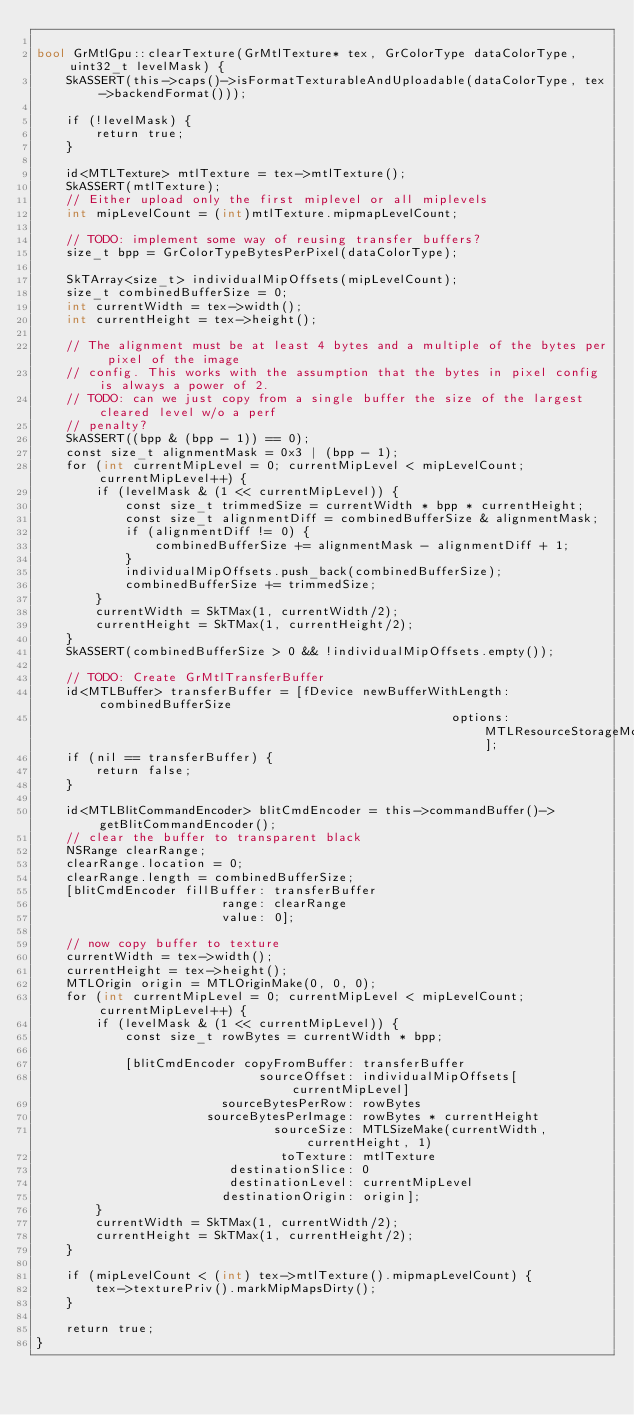<code> <loc_0><loc_0><loc_500><loc_500><_ObjectiveC_>
bool GrMtlGpu::clearTexture(GrMtlTexture* tex, GrColorType dataColorType, uint32_t levelMask) {
    SkASSERT(this->caps()->isFormatTexturableAndUploadable(dataColorType, tex->backendFormat()));

    if (!levelMask) {
        return true;
    }

    id<MTLTexture> mtlTexture = tex->mtlTexture();
    SkASSERT(mtlTexture);
    // Either upload only the first miplevel or all miplevels
    int mipLevelCount = (int)mtlTexture.mipmapLevelCount;

    // TODO: implement some way of reusing transfer buffers?
    size_t bpp = GrColorTypeBytesPerPixel(dataColorType);

    SkTArray<size_t> individualMipOffsets(mipLevelCount);
    size_t combinedBufferSize = 0;
    int currentWidth = tex->width();
    int currentHeight = tex->height();

    // The alignment must be at least 4 bytes and a multiple of the bytes per pixel of the image
    // config. This works with the assumption that the bytes in pixel config is always a power of 2.
    // TODO: can we just copy from a single buffer the size of the largest cleared level w/o a perf
    // penalty?
    SkASSERT((bpp & (bpp - 1)) == 0);
    const size_t alignmentMask = 0x3 | (bpp - 1);
    for (int currentMipLevel = 0; currentMipLevel < mipLevelCount; currentMipLevel++) {
        if (levelMask & (1 << currentMipLevel)) {
            const size_t trimmedSize = currentWidth * bpp * currentHeight;
            const size_t alignmentDiff = combinedBufferSize & alignmentMask;
            if (alignmentDiff != 0) {
                combinedBufferSize += alignmentMask - alignmentDiff + 1;
            }
            individualMipOffsets.push_back(combinedBufferSize);
            combinedBufferSize += trimmedSize;
        }
        currentWidth = SkTMax(1, currentWidth/2);
        currentHeight = SkTMax(1, currentHeight/2);
    }
    SkASSERT(combinedBufferSize > 0 && !individualMipOffsets.empty());

    // TODO: Create GrMtlTransferBuffer
    id<MTLBuffer> transferBuffer = [fDevice newBufferWithLength: combinedBufferSize
                                                        options: MTLResourceStorageModePrivate];
    if (nil == transferBuffer) {
        return false;
    }

    id<MTLBlitCommandEncoder> blitCmdEncoder = this->commandBuffer()->getBlitCommandEncoder();
    // clear the buffer to transparent black
    NSRange clearRange;
    clearRange.location = 0;
    clearRange.length = combinedBufferSize;
    [blitCmdEncoder fillBuffer: transferBuffer
                         range: clearRange
                         value: 0];

    // now copy buffer to texture
    currentWidth = tex->width();
    currentHeight = tex->height();
    MTLOrigin origin = MTLOriginMake(0, 0, 0);
    for (int currentMipLevel = 0; currentMipLevel < mipLevelCount; currentMipLevel++) {
        if (levelMask & (1 << currentMipLevel)) {
            const size_t rowBytes = currentWidth * bpp;

            [blitCmdEncoder copyFromBuffer: transferBuffer
                              sourceOffset: individualMipOffsets[currentMipLevel]
                         sourceBytesPerRow: rowBytes
                       sourceBytesPerImage: rowBytes * currentHeight
                                sourceSize: MTLSizeMake(currentWidth, currentHeight, 1)
                                 toTexture: mtlTexture
                          destinationSlice: 0
                          destinationLevel: currentMipLevel
                         destinationOrigin: origin];
        }
        currentWidth = SkTMax(1, currentWidth/2);
        currentHeight = SkTMax(1, currentHeight/2);
    }

    if (mipLevelCount < (int) tex->mtlTexture().mipmapLevelCount) {
        tex->texturePriv().markMipMapsDirty();
    }

    return true;
}
</code> 